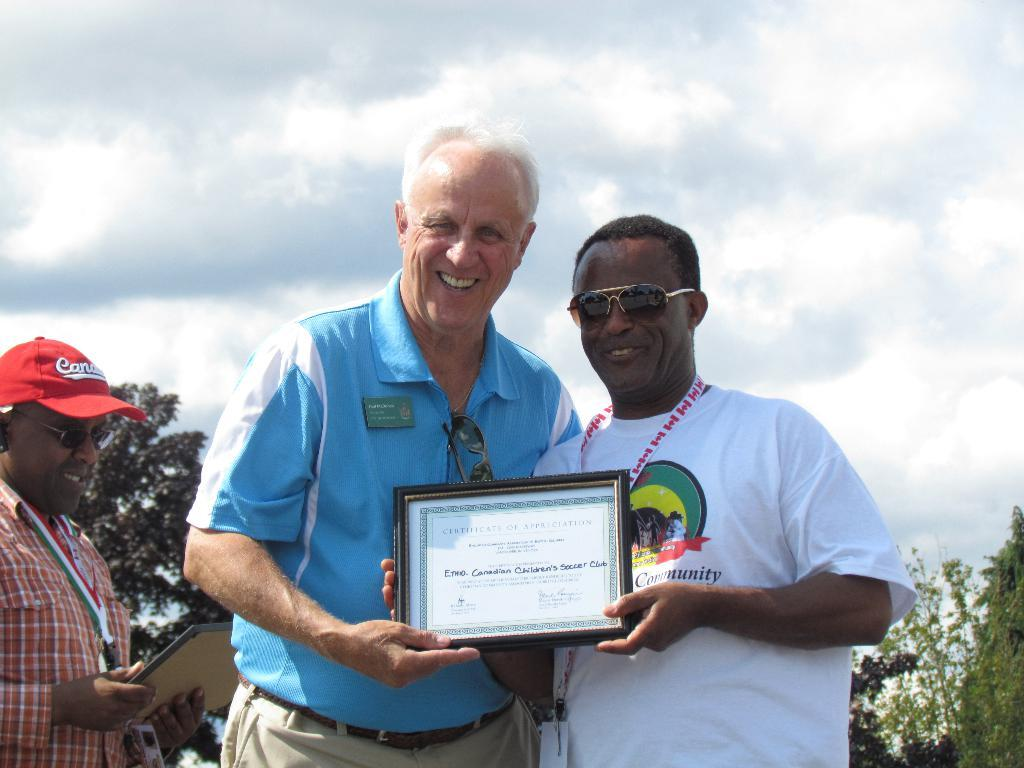How many people are in the image? There are three men in the image. What are the men doing in the image? The men are standing and holding frames. What can be seen in the background of the image? There are trees and the sky visible in the background of the image. What is the condition of the sky in the image? Clouds are present in the sky. What type of space vehicle can be seen in the image? There is no space vehicle present in the image; it features three men standing and holding frames. What is the reason for the men to stop in the image? The image does not provide any information about why the men are standing or if they are stopping; they are simply holding frames. 